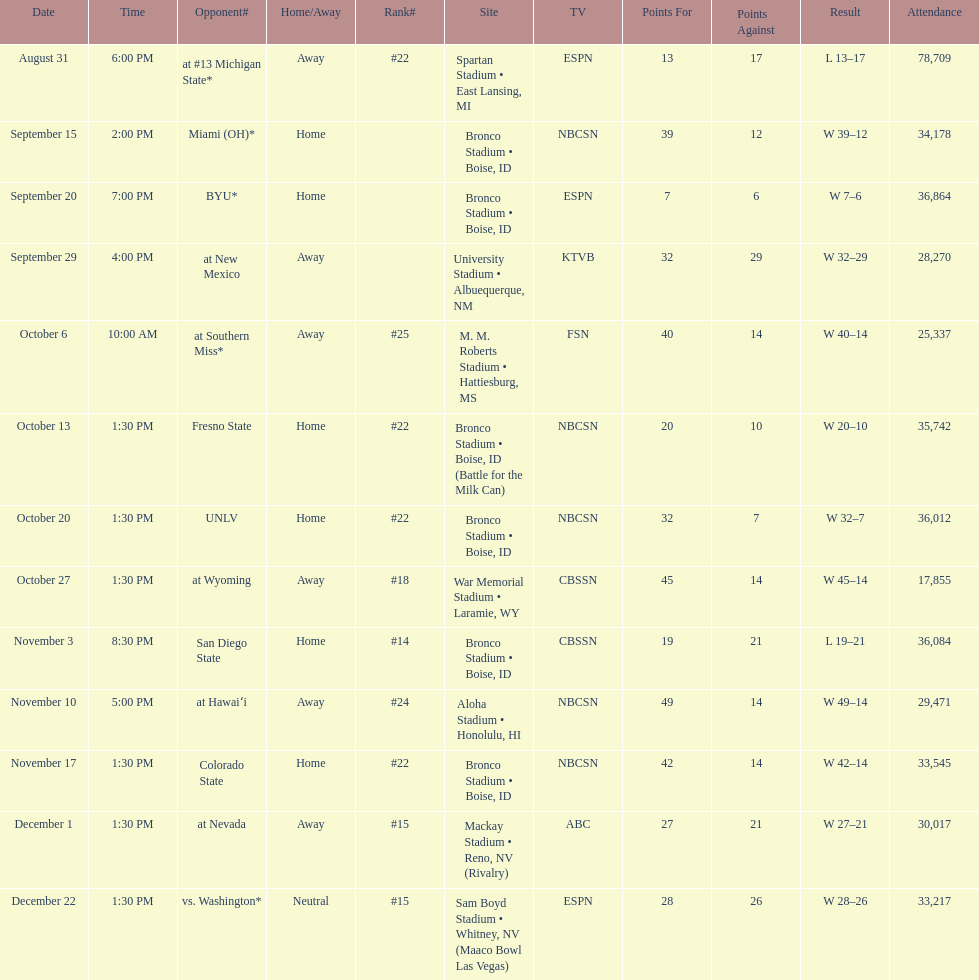What is the score difference for the game against michigan state? 4. 